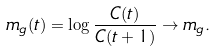<formula> <loc_0><loc_0><loc_500><loc_500>m _ { g } ( t ) = \log \frac { C ( t ) } { C ( t + 1 ) } \rightarrow m _ { g } .</formula> 